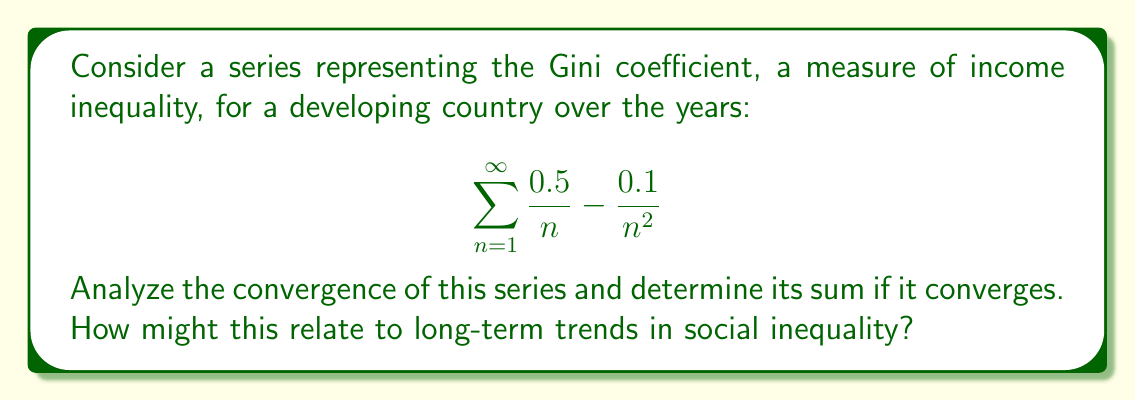Can you answer this question? Let's approach this step-by-step:

1) First, we need to determine if the series converges. We can do this by using the limit comparison test with two well-known series:

   a) $\sum_{n=1}^{\infty} \frac{1}{n}$ (the harmonic series, which diverges)
   b) $\sum_{n=1}^{\infty} \frac{1}{n^2}$ (the p-series with p=2, which converges)

2) Let's call our series $a_n = \frac{0.5}{n} - \frac{0.1}{n^2}$

3) Compare with $\frac{1}{n}$:
   
   $$\lim_{n \to \infty} \frac{a_n}{\frac{1}{n}} = \lim_{n \to \infty} \frac{\frac{0.5}{n} - \frac{0.1}{n^2}}{\frac{1}{n}} = \lim_{n \to \infty} (0.5 - \frac{0.1}{n}) = 0.5$$

   Since this limit is non-zero and finite, $a_n$ behaves like $\frac{1}{n}$ as $n$ approaches infinity. Therefore, this part of the series diverges.

4) Compare with $\frac{1}{n^2}$:
   
   $$\lim_{n \to \infty} \frac{a_n}{\frac{1}{n^2}} = \lim_{n \to \infty} \frac{\frac{0.5}{n} - \frac{0.1}{n^2}}{\frac{1}{n^2}} = \lim_{n \to \infty} (0.5n - 0.1) = \infty$$

   This means $a_n$ doesn't approach zero as fast as $\frac{1}{n^2}$, so we can't conclude convergence from this comparison.

5) Given these results, we can conclude that the series diverges due to the $\frac{0.5}{n}$ term.

6) Although the series diverges, we can interpret its behavior in the context of social inequality:
   - The $\frac{0.5}{n}$ term suggests a slow decrease in inequality over time.
   - The $\frac{0.1}{n^2}$ term indicates an even slower additional decrease.
   - The divergence of the series could imply that while inequality may decrease, it might never reach perfect equality (Gini coefficient of 0) in this model.

This analysis shows that while there might be a trend towards reduced inequality, the process is very slow and may never reach completion, highlighting the persistent nature of social inequality.
Answer: The series diverges due to the $\frac{0.5}{n}$ term, which behaves like the harmonic series. This divergence suggests that while inequality may decrease over time, it may never reach perfect equality in this model. 